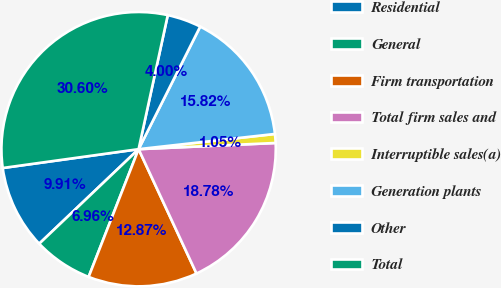Convert chart. <chart><loc_0><loc_0><loc_500><loc_500><pie_chart><fcel>Residential<fcel>General<fcel>Firm transportation<fcel>Total firm sales and<fcel>Interruptible sales(a)<fcel>Generation plants<fcel>Other<fcel>Total<nl><fcel>9.91%<fcel>6.96%<fcel>12.87%<fcel>18.78%<fcel>1.05%<fcel>15.82%<fcel>4.0%<fcel>30.6%<nl></chart> 